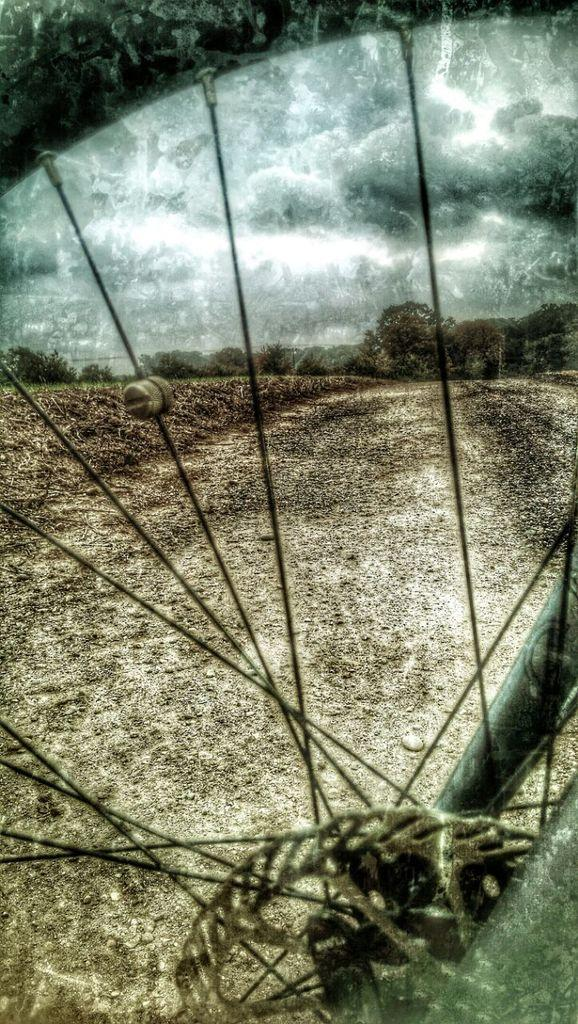What can be seen in the sky in the image? The sky is visible in the image. What can be seen on the ground in the image? The ground is visible in the image. What type of vegetation is present in the image? There are trees in the image. What type of object is present in the image that is related to a bicycle? There is a bicycle wheel in the image. What are the features of the bicycle wheel? The bicycle wheel has nipples, spokes, a chain, and rods. Who won the competition in the image? There is no competition present in the image. How many bikes are visible in the image? There is only one bicycle wheel visible in the image, not a complete bike. What type of wound can be seen on the trees in the image? There are no wounds visible on the trees in the image. 